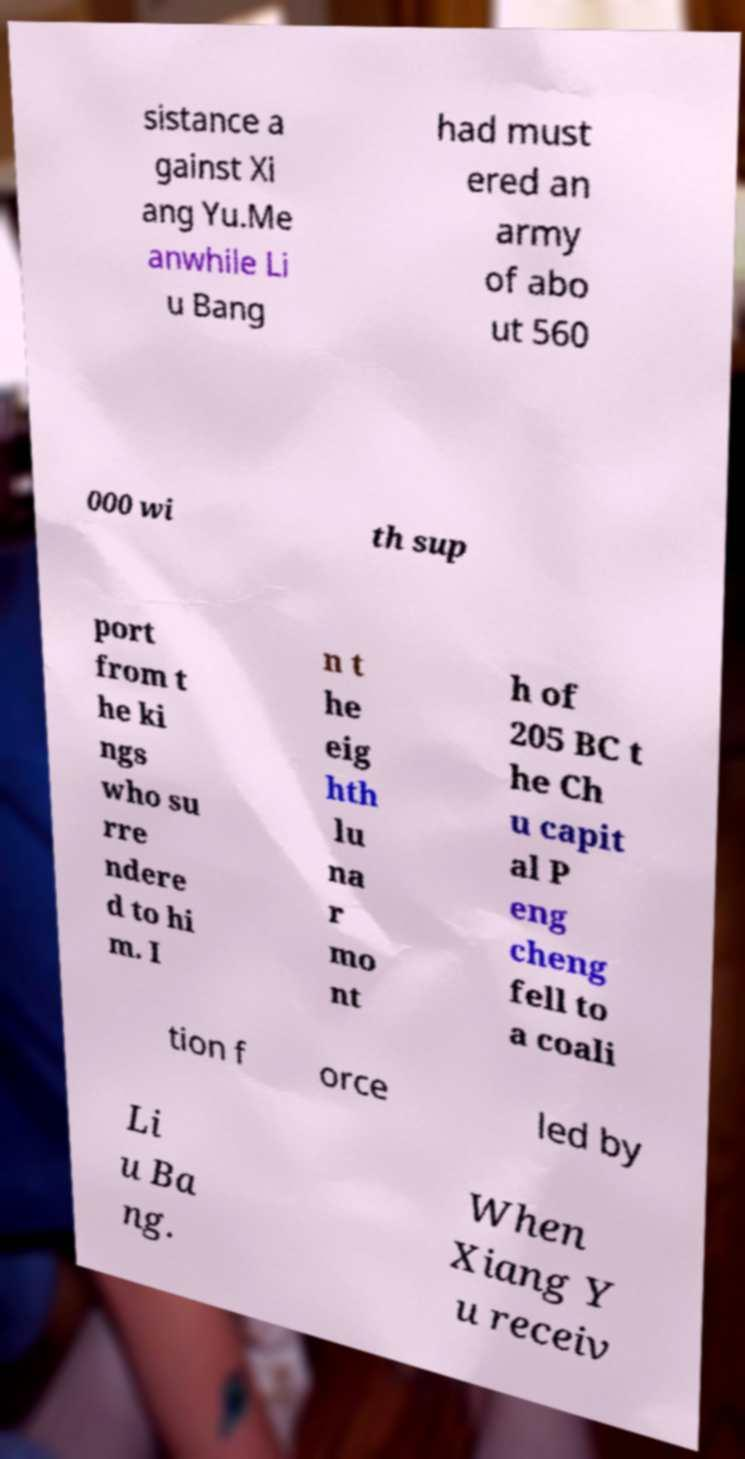I need the written content from this picture converted into text. Can you do that? sistance a gainst Xi ang Yu.Me anwhile Li u Bang had must ered an army of abo ut 560 000 wi th sup port from t he ki ngs who su rre ndere d to hi m. I n t he eig hth lu na r mo nt h of 205 BC t he Ch u capit al P eng cheng fell to a coali tion f orce led by Li u Ba ng. When Xiang Y u receiv 